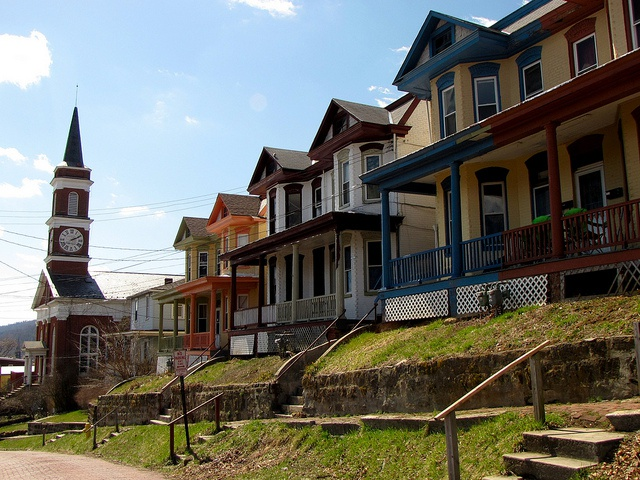Describe the objects in this image and their specific colors. I can see clock in lightblue, gray, and black tones and clock in lightblue, gray, black, and purple tones in this image. 